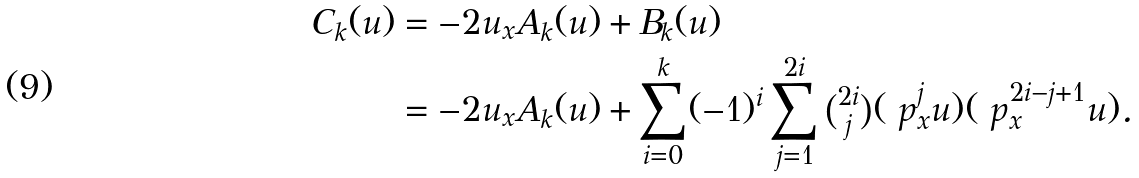Convert formula to latex. <formula><loc_0><loc_0><loc_500><loc_500>C _ { k } ( u ) & = - 2 u _ { x } A _ { k } ( u ) + B _ { k } ( u ) \\ & = - 2 u _ { x } A _ { k } ( u ) + \sum _ { i = 0 } ^ { k } ( - 1 ) ^ { i } \sum _ { j = 1 } ^ { 2 i } \tbinom { 2 i } { j } ( \ p _ { x } ^ { j } u ) ( \ p _ { x } ^ { 2 i - j + 1 } u ) .</formula> 